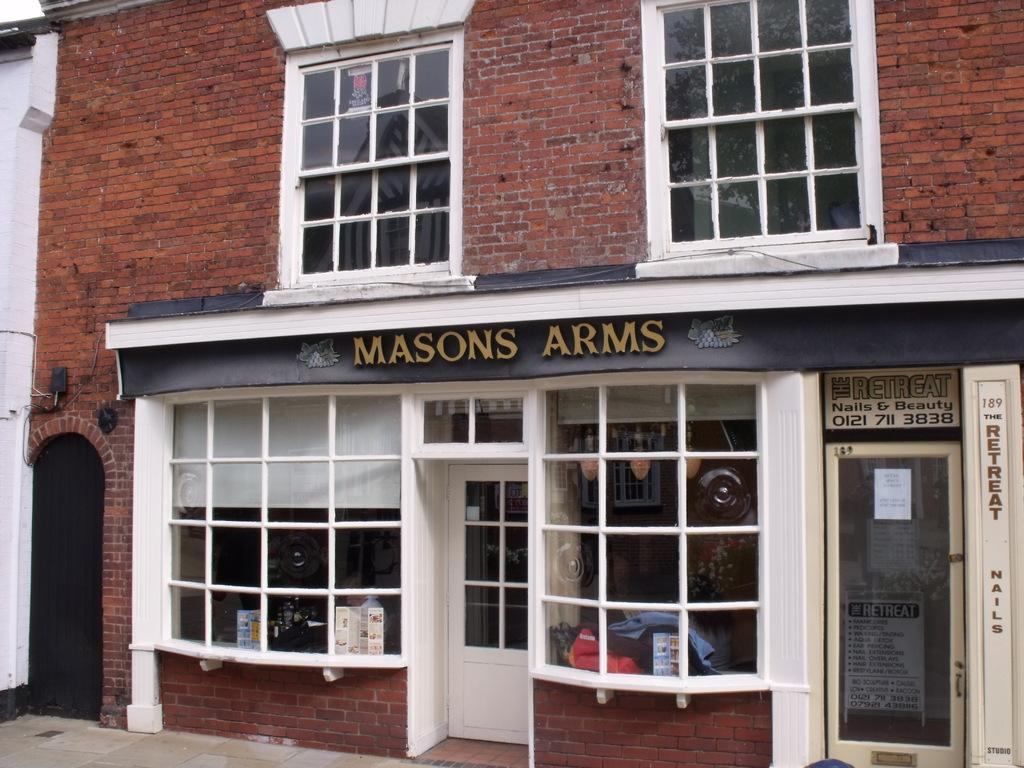What type of structure is visible in the image? There is a building with windows in the image. Where are the windows located on the building? The windows are in the middle of the building. What is located below the building in the image? There is a house below the building. How many doors does the house have? The house has two doors. What type of windows does the house have? The house has glass windows. What flavor of cake is being served at the sailing event in the image? There is no sailing event or cake present in the image. 